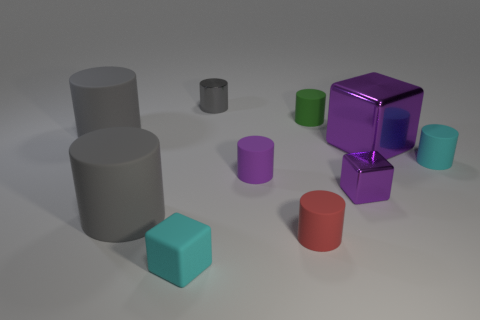Can you tell me about the lighting in the image? Does it seem natural or artificial? The lighting in the image appears artificial, likely from a simulated or studio light source. It casts soft shadows and highlights on objects, suggesting a diffuse light commonly used in rendering or photography studios. 